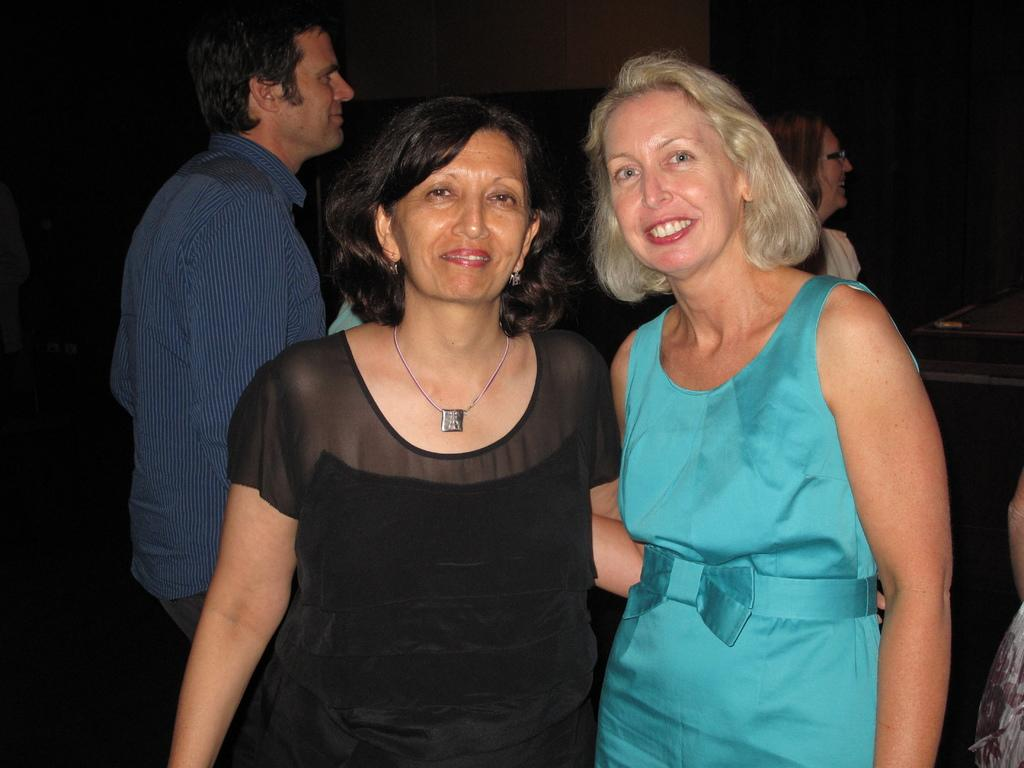How many women are in the image? There are two women standing in the image. What is the facial expression of the women in the image? The women are smiling. Can you describe the people in the background of the image? There are two people in the background of the image, and they are also smiling. What is the color of the background in the image? The background of the image is dark. What type of collar is the dad wearing in the image? There is no dad present in the image, and therefore no collar to describe. 